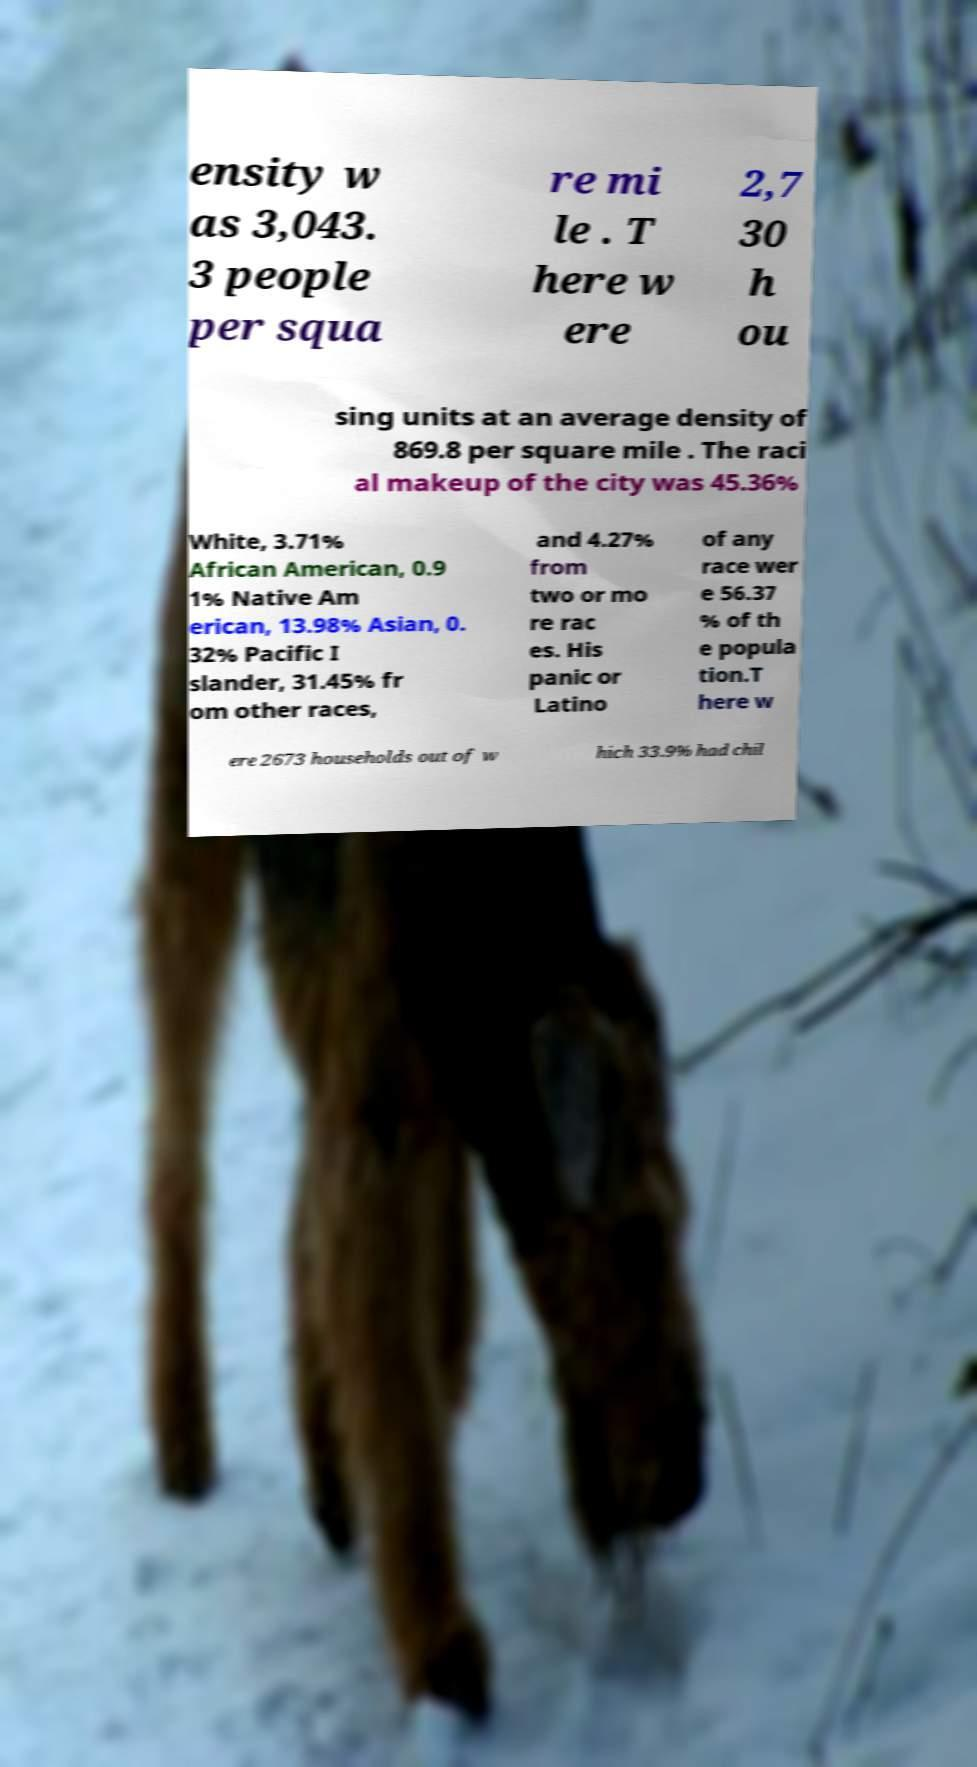There's text embedded in this image that I need extracted. Can you transcribe it verbatim? ensity w as 3,043. 3 people per squa re mi le . T here w ere 2,7 30 h ou sing units at an average density of 869.8 per square mile . The raci al makeup of the city was 45.36% White, 3.71% African American, 0.9 1% Native Am erican, 13.98% Asian, 0. 32% Pacific I slander, 31.45% fr om other races, and 4.27% from two or mo re rac es. His panic or Latino of any race wer e 56.37 % of th e popula tion.T here w ere 2673 households out of w hich 33.9% had chil 